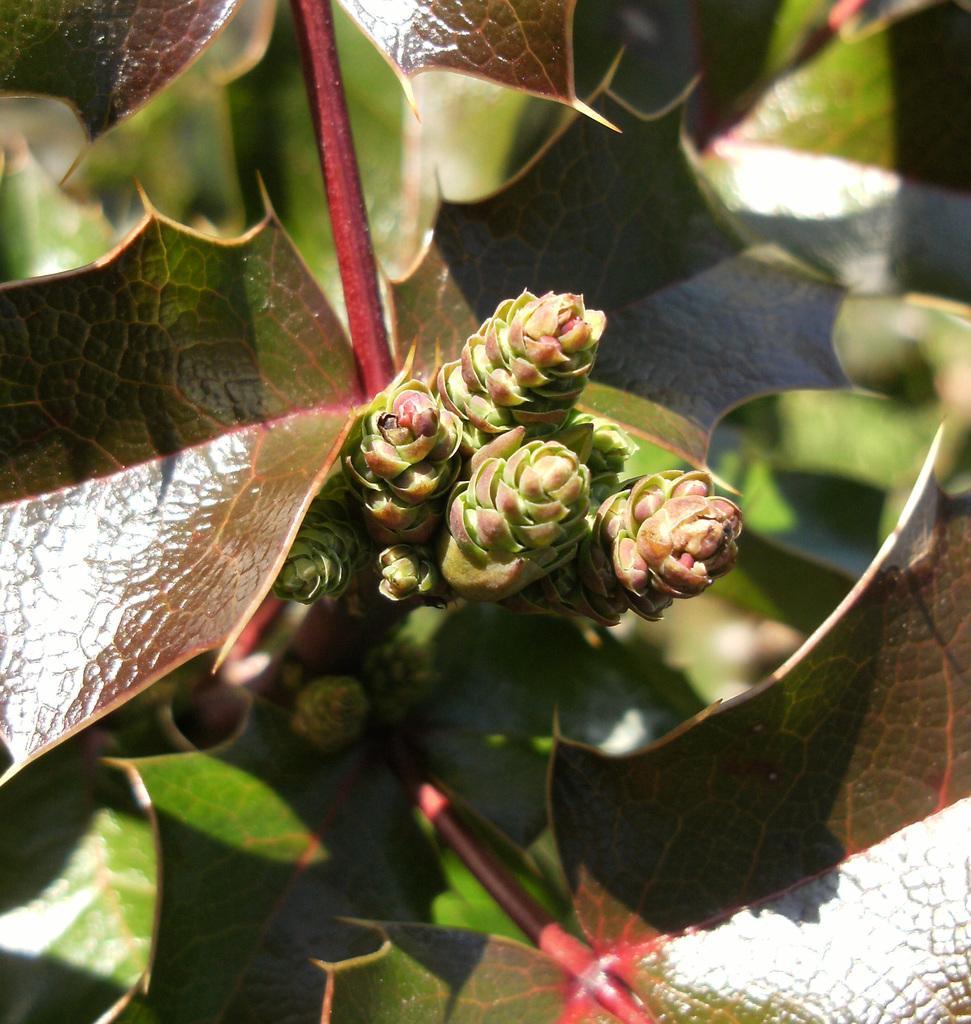Describe this image in one or two sentences. In this image there are buds to the plant. At the bottom there are green leaves. 